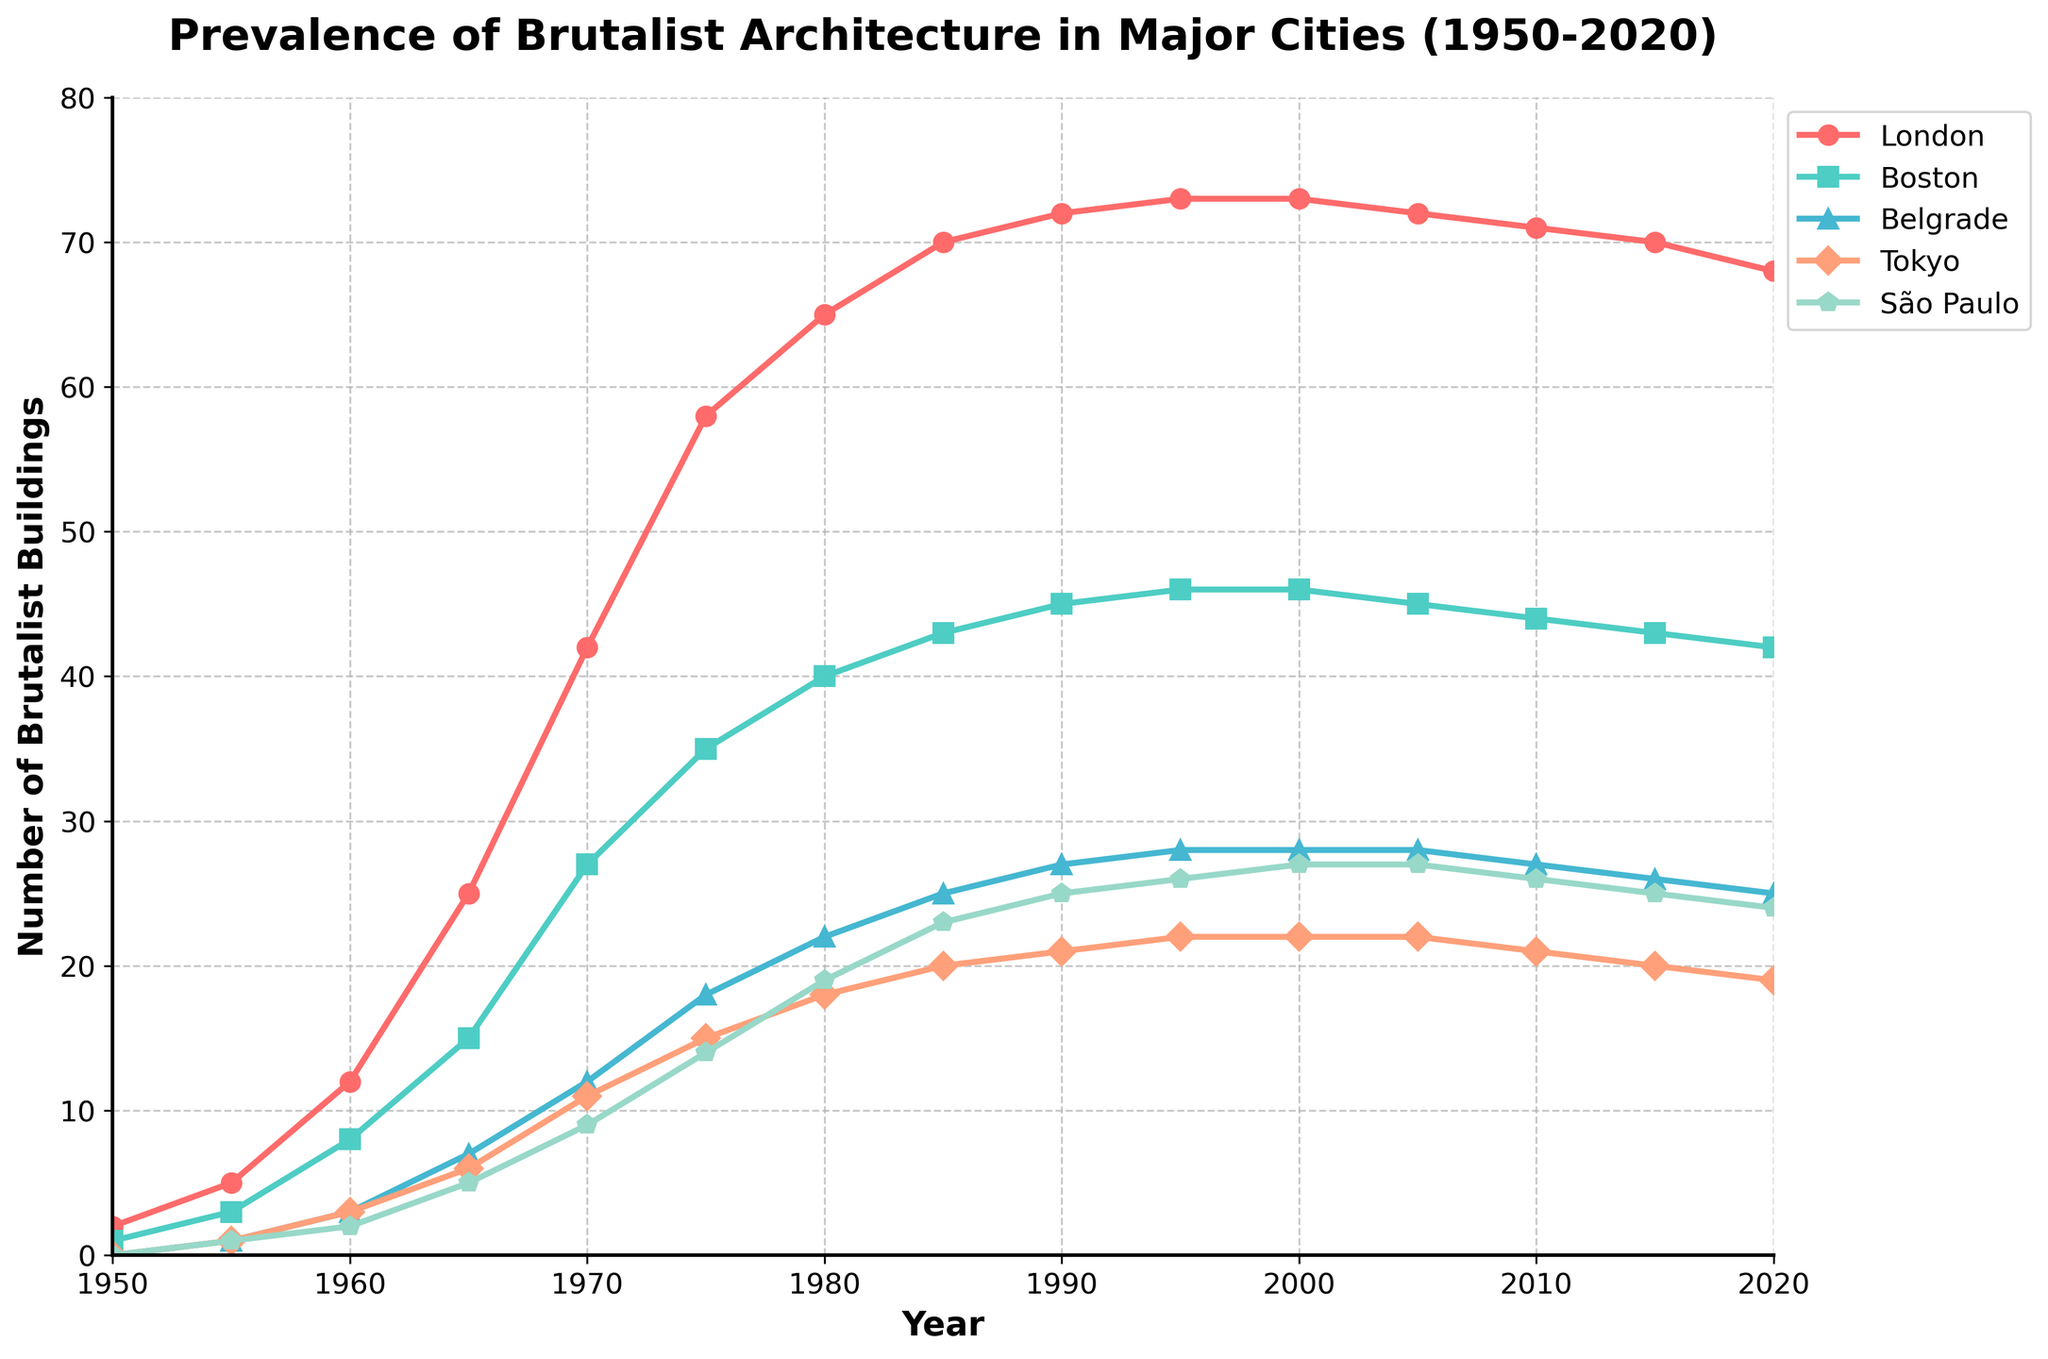Which city had the highest number of Brutalist buildings in 1970? In 1970, looking at the value for each city, London had 42, Boston had 27, Belgrade had 12, Tokyo had 11, and São Paulo had 9. London has the highest number.
Answer: London What is the total number of Brutalist buildings added across all cities from 1960 to 1970? In 1960, the sums for all cities are: 12 (London) + 8 (Boston) + 3 (Belgrade) + 3 (Tokyo) + 2 (São Paulo) = 28. In 1970, the sums are: 42 (London) + 27 (Boston) + 12 (Belgrade) + 11 (Tokyo) + 9 (São Paulo) = 101. The difference is 101 - 28 = 73.
Answer: 73 Between which years did São Paulo see the greatest increase in Brutalist buildings? Observing the data for São Paulo, the greatest increase is from 1965 (5) to 1970 (9), which is 4 buildings. This is the largest increase seen across any five-year interval.
Answer: 1965 to 1970 In which decade did Tokyo experience the largest increase in Brutalist buildings' prevalence? Looking at Tokyo's numbers: 1950 (0) to 1960 (3), 1960 to 1970 (11), 1970 to 1980 (18), 1980 to 1990 (21), 1990 to 2000 (22), 2000 to 2010 (21). The largest increase is from 1960 to 1970, with an increase of 8 buildings.
Answer: 1960 to 1970 How does the prevalence of Brutalist buildings in Boston change from 1995 to 2020? For Boston, the count is: 1995 (46), 2000 (46), 2005 (45), 2010 (44), 2015 (43), 2020 (42). The count decreases consistently from 46 in 1995 to 42 in 2020, thus the overall change is a decrease of 4 buildings.
Answer: Decreased by 4 What is the approximate average number of Brutalist buildings across all cities in 1980? In 1980, the counts are: London (65), Boston (40), Belgrade (22), Tokyo (18), São Paulo (19). Summing these: 65 + 40 + 22 + 18 + 19 = 164. Dividing by 5 cities gives 164 / 5 = 32.8.
Answer: 32.8 Which city had the least growth in the number of Brutalist buildings from 1950 to 1980? Calculating the growth from 1950 to 1980: London (65 - 2 = 63), Boston (40 - 1 = 39), Belgrade (22 - 0 = 22), Tokyo (18 - 0 = 18), São Paulo (19 - 0 = 19). Tokyo had the least growth with an increase of 18 buildings.
Answer: Tokyo What is the difference in Brutalist building prevalence between London and Belgrade in 2020? For 2020, London has 68 buildings, while Belgrade has 25 buildings. The difference is 68 - 25 = 43.
Answer: 43 During which 10-year interval did São Paulo experience no growth in the number of Brutalist buildings? Reviewing São Paulo’s data from 2000 (27) to 2010 (26), there are no increases, reflecting no growth.
Answer: 2000 to 2010 